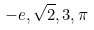<formula> <loc_0><loc_0><loc_500><loc_500>- e , \sqrt { 2 } , 3 , \pi</formula> 